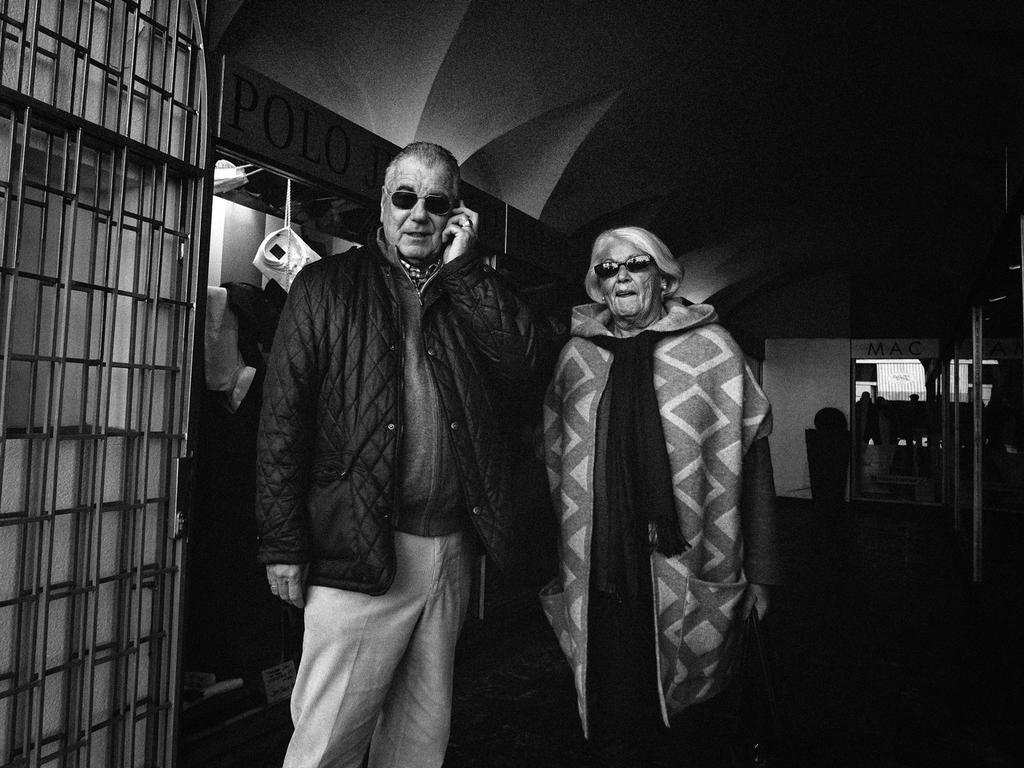Describe this image in one or two sentences. In this image we can see two persons standing, a person is holding an object, there are few clothes beside them and there is a grille in front of them and few objects in the background. 